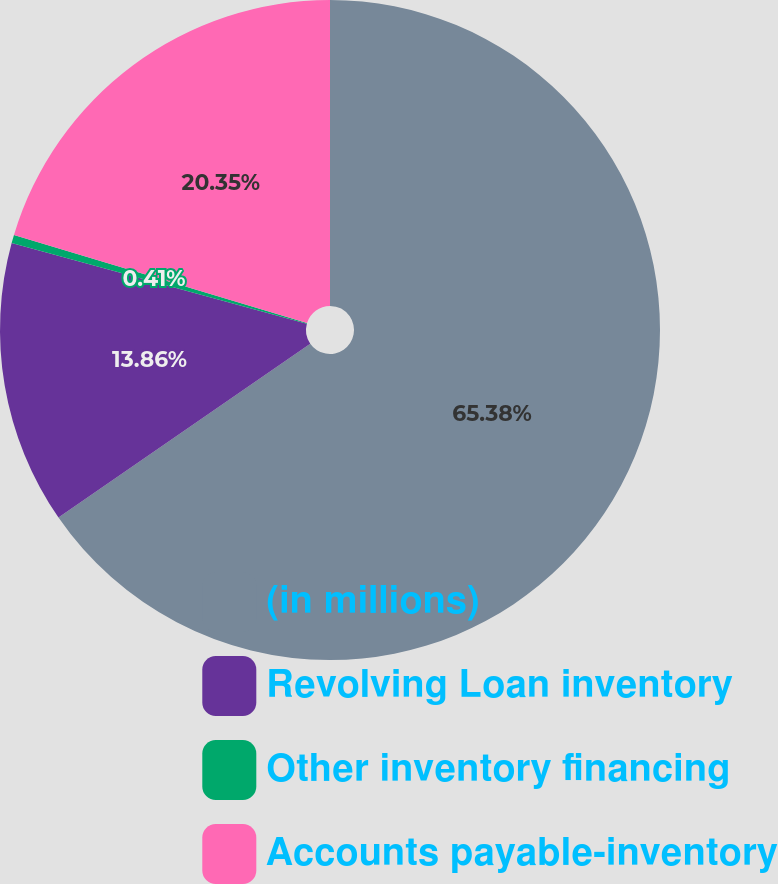Convert chart. <chart><loc_0><loc_0><loc_500><loc_500><pie_chart><fcel>(in millions)<fcel>Revolving Loan inventory<fcel>Other inventory financing<fcel>Accounts payable-inventory<nl><fcel>65.38%<fcel>13.86%<fcel>0.41%<fcel>20.35%<nl></chart> 